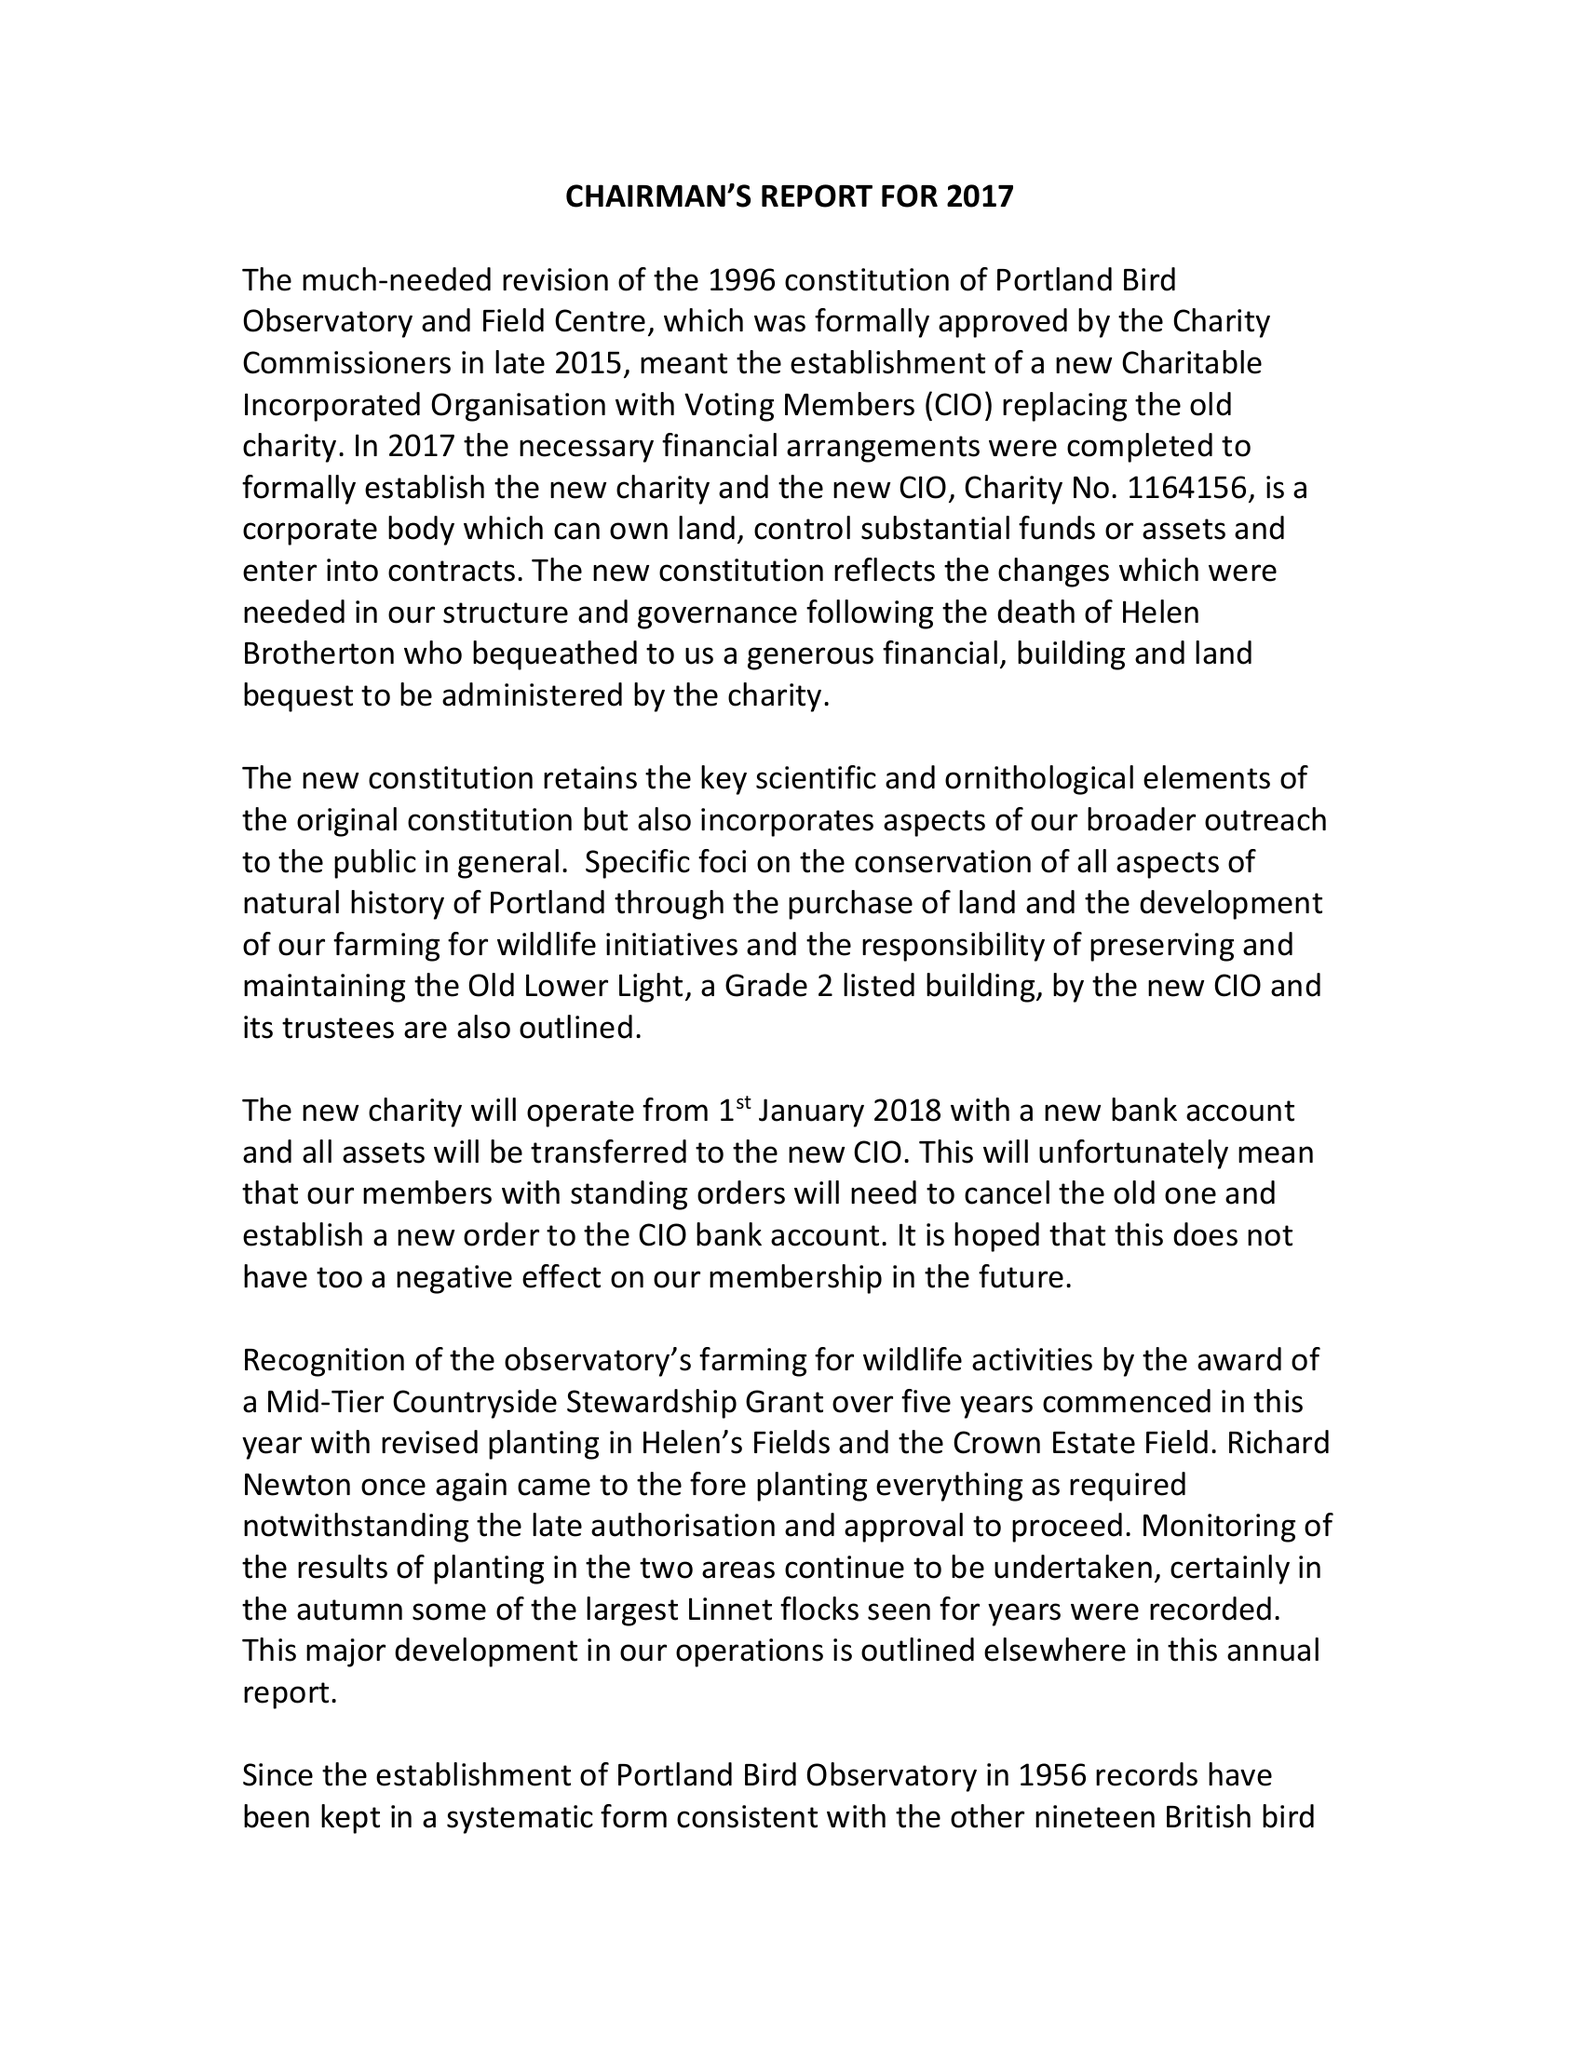What is the value for the address__postcode?
Answer the question using a single word or phrase. DT5 2JT 